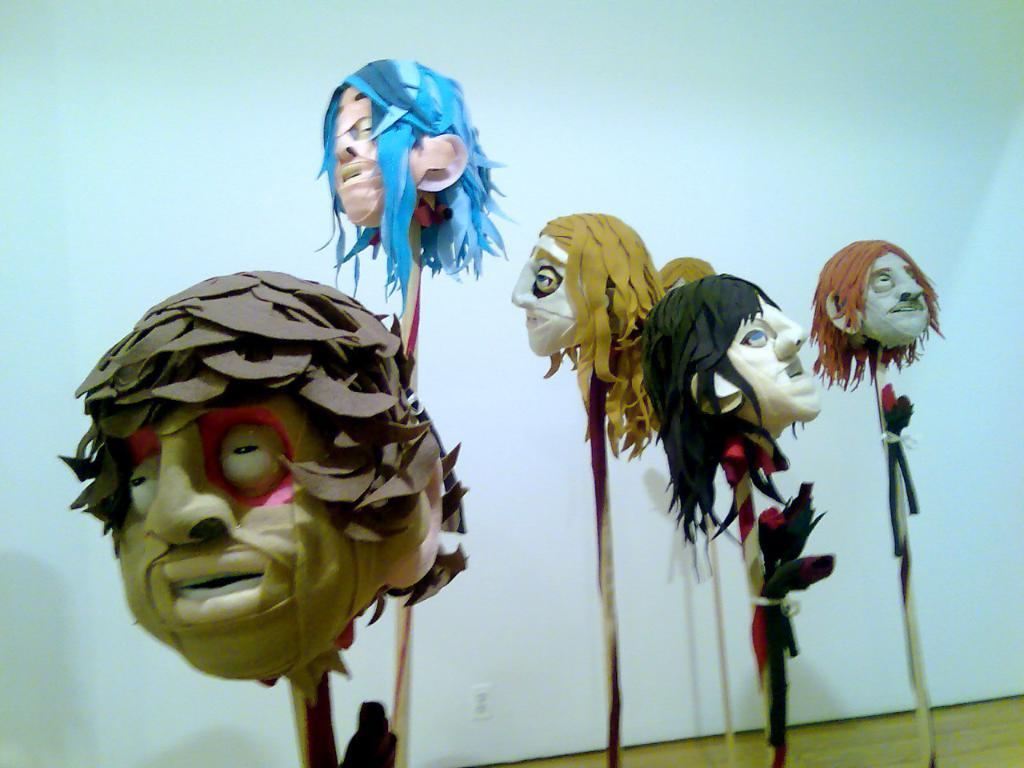What type of toys are present in the image? There are monster toy dolls in the image. What part of the monster toy dolls can be seen in the image? The monster toy dolls have heads visible in the image. What structures are present in the image? There are poles in the image. What type of flooring is visible in the right bottom of the image? There is a wooden floor in the right bottom of the image. What can be seen in the background of the image? There is a white wall in the background of the image. Where is the plantation located in the image? There is no plantation present in the image. What type of bike can be seen in the image? There is no bike present in the image. 